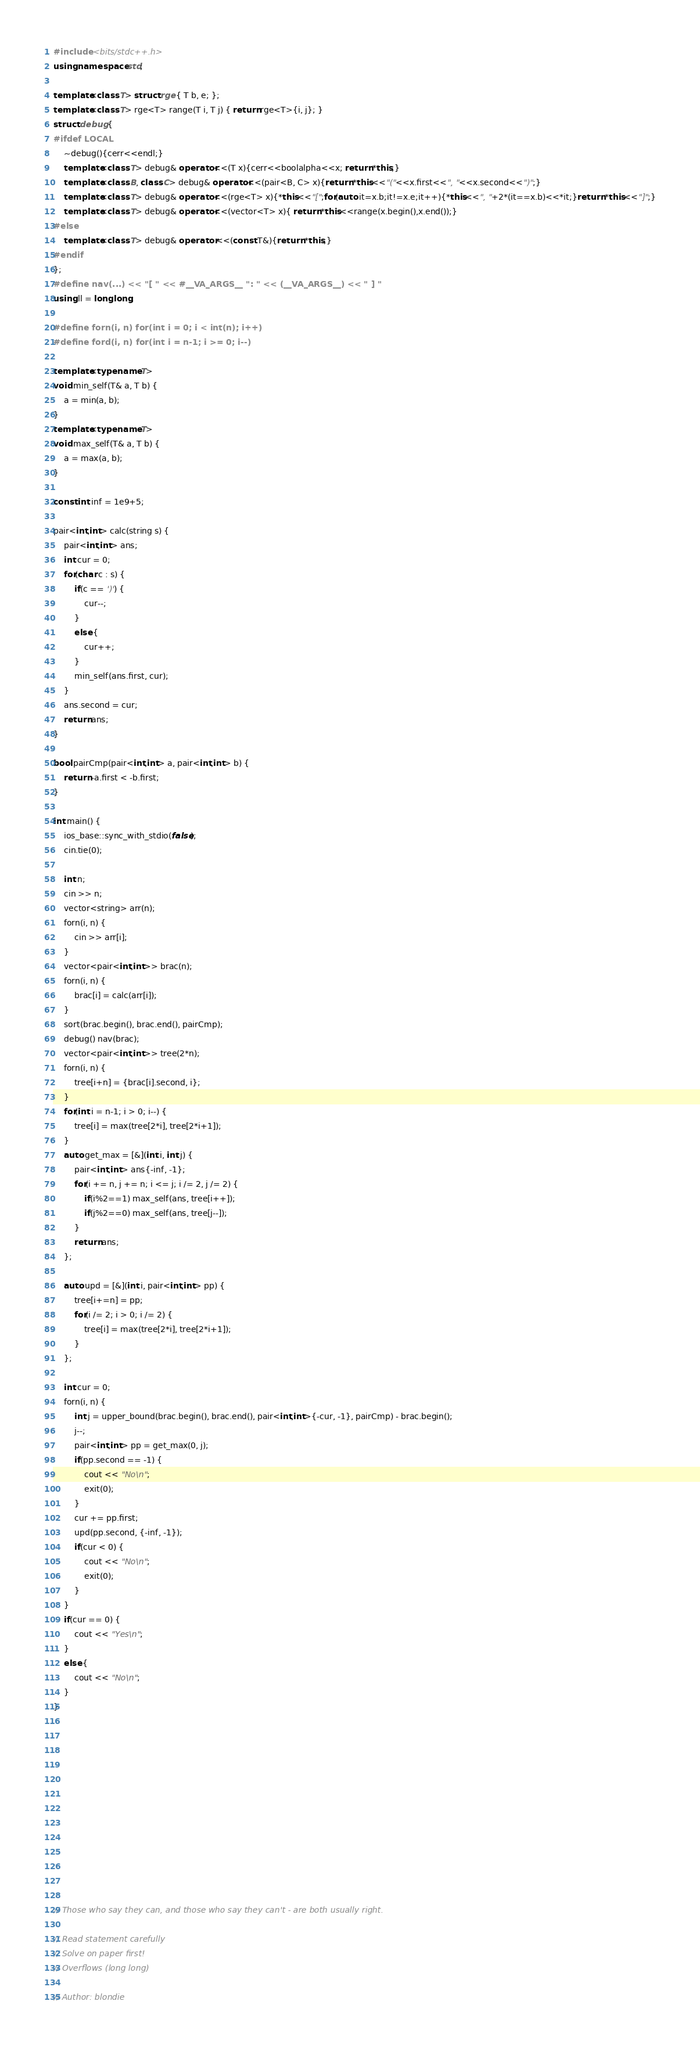<code> <loc_0><loc_0><loc_500><loc_500><_C++_>#include <bits/stdc++.h>
using namespace std;

template<class T> struct rge { T b, e; };
template<class T> rge<T> range(T i, T j) { return rge<T>{i, j}; }
struct debug {
#ifdef LOCAL
    ~debug(){cerr<<endl;}
    template<class T> debug& operator<<(T x){cerr<<boolalpha<<x; return *this;}
    template<class B, class C> debug& operator<<(pair<B, C> x){return *this<<"("<<x.first<<", "<<x.second<<")";}
    template<class T> debug& operator<<(rge<T> x){*this<<"[";for(auto it=x.b;it!=x.e;it++){*this<<", "+2*(it==x.b)<<*it;}return *this<<"]";}
    template<class T> debug& operator<<(vector<T> x){ return *this<<range(x.begin(),x.end());}
#else
    template<class T> debug& operator <<(const T&){return *this;}
#endif
};
#define nav(...) << "[ " << #__VA_ARGS__ ": " << (__VA_ARGS__) << " ] "
using ll = long long;

#define forn(i, n) for(int i = 0; i < int(n); i++)
#define ford(i, n) for(int i = n-1; i >= 0; i--) 

template<typename T> 
void min_self(T& a, T b) { 
    a = min(a, b); 
}
template<typename T>
void max_self(T& a, T b) { 
    a = max(a, b); 
}

const int inf = 1e9+5;

pair<int,int> calc(string s) {
    pair<int,int> ans;
    int cur = 0;
    for(char c : s) {
        if(c == ')') {
            cur--;
        }
        else {
            cur++;
        }
        min_self(ans.first, cur);
    }
    ans.second = cur;
    return ans;
}

bool pairCmp(pair<int,int> a, pair<int,int> b) {
    return -a.first < -b.first;
}

int main() {
    ios_base::sync_with_stdio(false);
    cin.tie(0);

    int n;
    cin >> n;
    vector<string> arr(n);
    forn(i, n) {
        cin >> arr[i];
    }
    vector<pair<int,int>> brac(n);
    forn(i, n) {
        brac[i] = calc(arr[i]);
    }
    sort(brac.begin(), brac.end(), pairCmp);
    debug() nav(brac);
    vector<pair<int,int>> tree(2*n);
    forn(i, n) {
        tree[i+n] = {brac[i].second, i};
    }
    for(int i = n-1; i > 0; i--) {
        tree[i] = max(tree[2*i], tree[2*i+1]);
    }
    auto get_max = [&](int i, int j) {
        pair<int,int> ans{-inf, -1};
        for(i += n, j += n; i <= j; i /= 2, j /= 2) {
            if(i%2==1) max_self(ans, tree[i++]);
            if(j%2==0) max_self(ans, tree[j--]);
        }
        return ans;
    };
    
    auto upd = [&](int i, pair<int,int> pp) {
        tree[i+=n] = pp;
        for(i /= 2; i > 0; i /= 2) {
            tree[i] = max(tree[2*i], tree[2*i+1]);
        }
    };
    
    int cur = 0;
    forn(i, n) {
        int j = upper_bound(brac.begin(), brac.end(), pair<int,int>{-cur, -1}, pairCmp) - brac.begin();
        j--;
        pair<int,int> pp = get_max(0, j);
        if(pp.second == -1) {
            cout << "No\n";
            exit(0);
        }
        cur += pp.first;
        upd(pp.second, {-inf, -1});
        if(cur < 0) {
            cout << "No\n";
            exit(0);
        }
    }
    if(cur == 0) {
        cout << "Yes\n";
    }
    else {
        cout << "No\n";
    }
}













// Those who say they can, and those who say they can't - are both usually right.

// Read statement carefully
// Solve on paper first!
// Overflows (long long)

// Author: blondie
</code> 